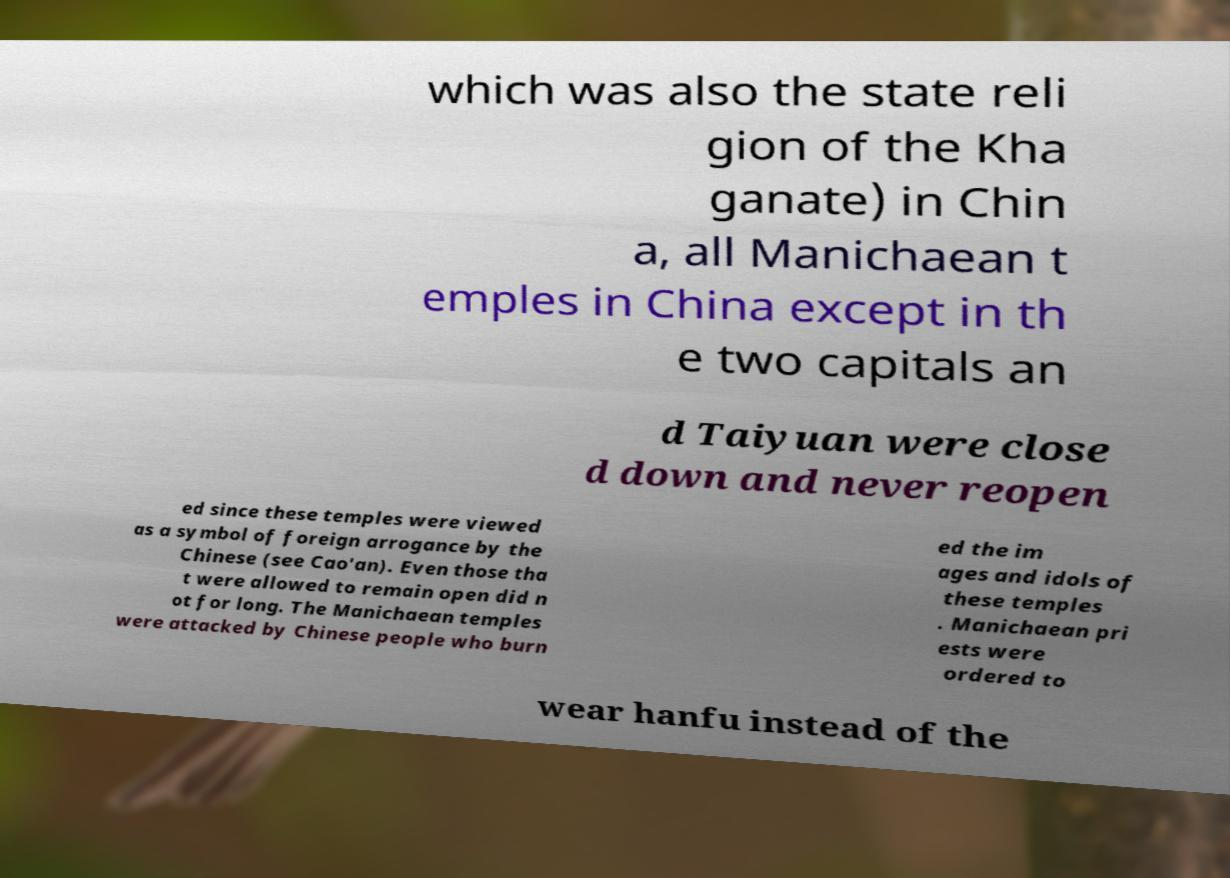Can you accurately transcribe the text from the provided image for me? which was also the state reli gion of the Kha ganate) in Chin a, all Manichaean t emples in China except in th e two capitals an d Taiyuan were close d down and never reopen ed since these temples were viewed as a symbol of foreign arrogance by the Chinese (see Cao'an). Even those tha t were allowed to remain open did n ot for long. The Manichaean temples were attacked by Chinese people who burn ed the im ages and idols of these temples . Manichaean pri ests were ordered to wear hanfu instead of the 